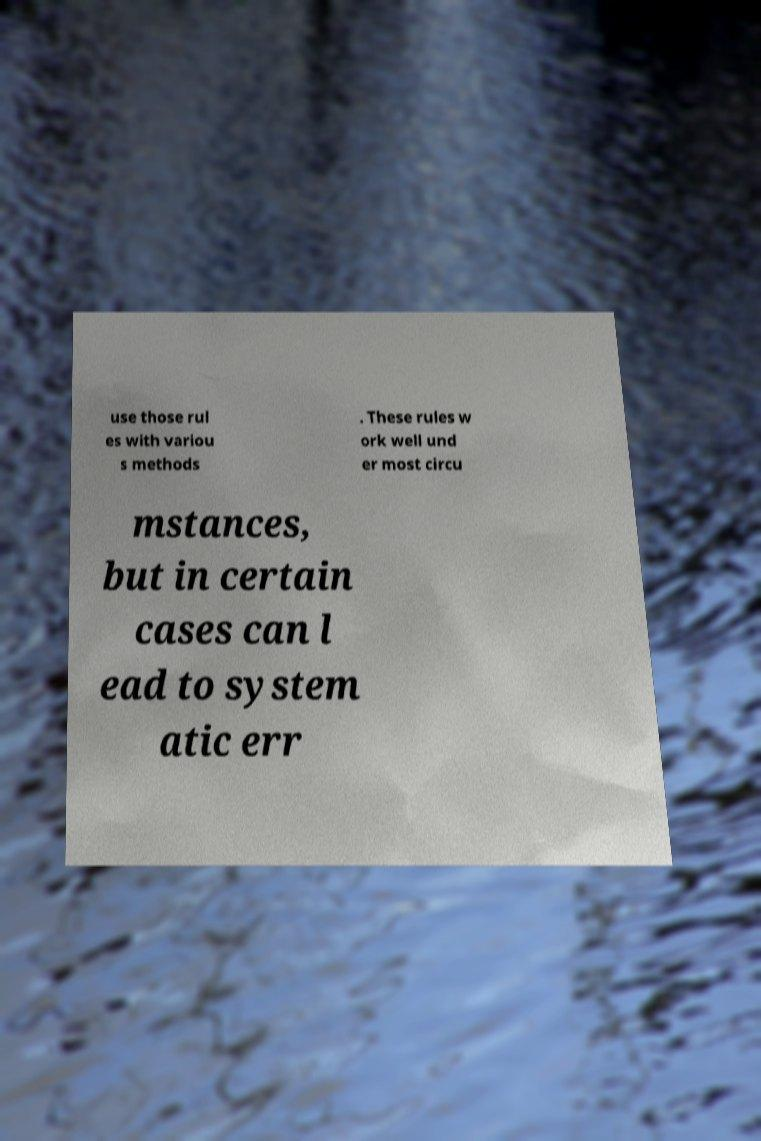What messages or text are displayed in this image? I need them in a readable, typed format. use those rul es with variou s methods . These rules w ork well und er most circu mstances, but in certain cases can l ead to system atic err 